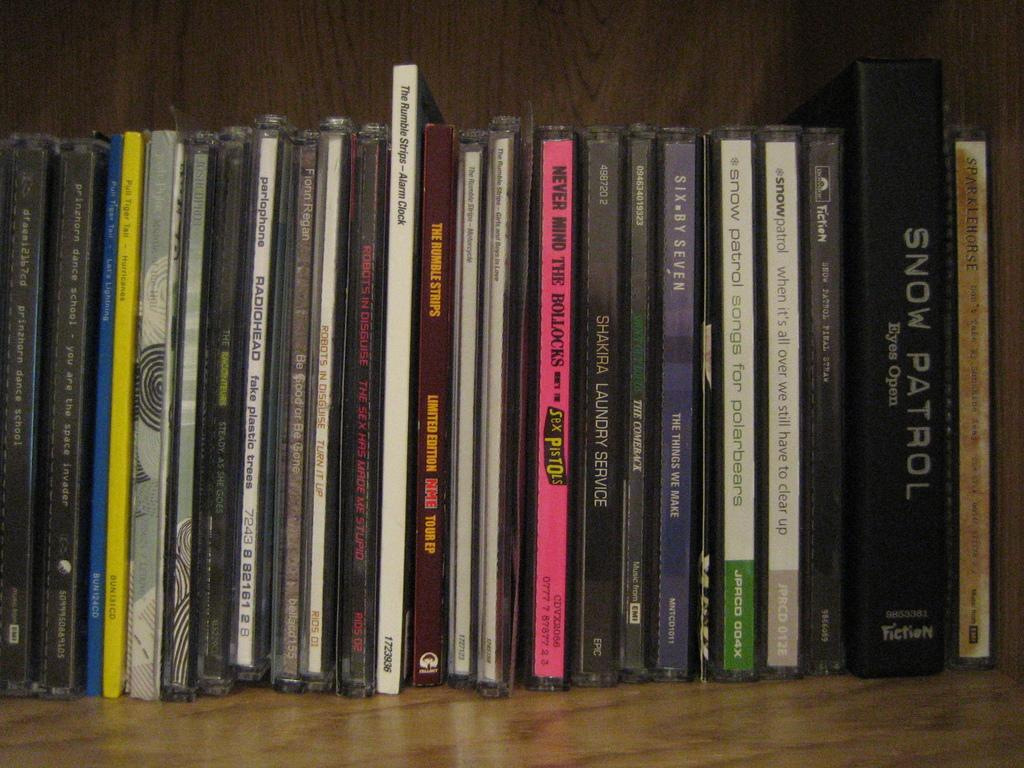<image>
Share a concise interpretation of the image provided. A row of compact disks lined up including a one shakira album 